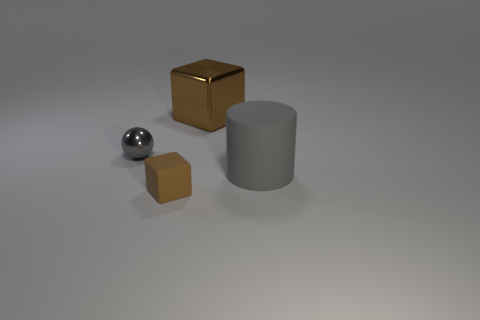Add 1 small gray metal spheres. How many objects exist? 5 Subtract all balls. How many objects are left? 3 Subtract all big green shiny objects. Subtract all gray objects. How many objects are left? 2 Add 2 tiny brown matte cubes. How many tiny brown matte cubes are left? 3 Add 1 big gray objects. How many big gray objects exist? 2 Subtract 0 blue spheres. How many objects are left? 4 